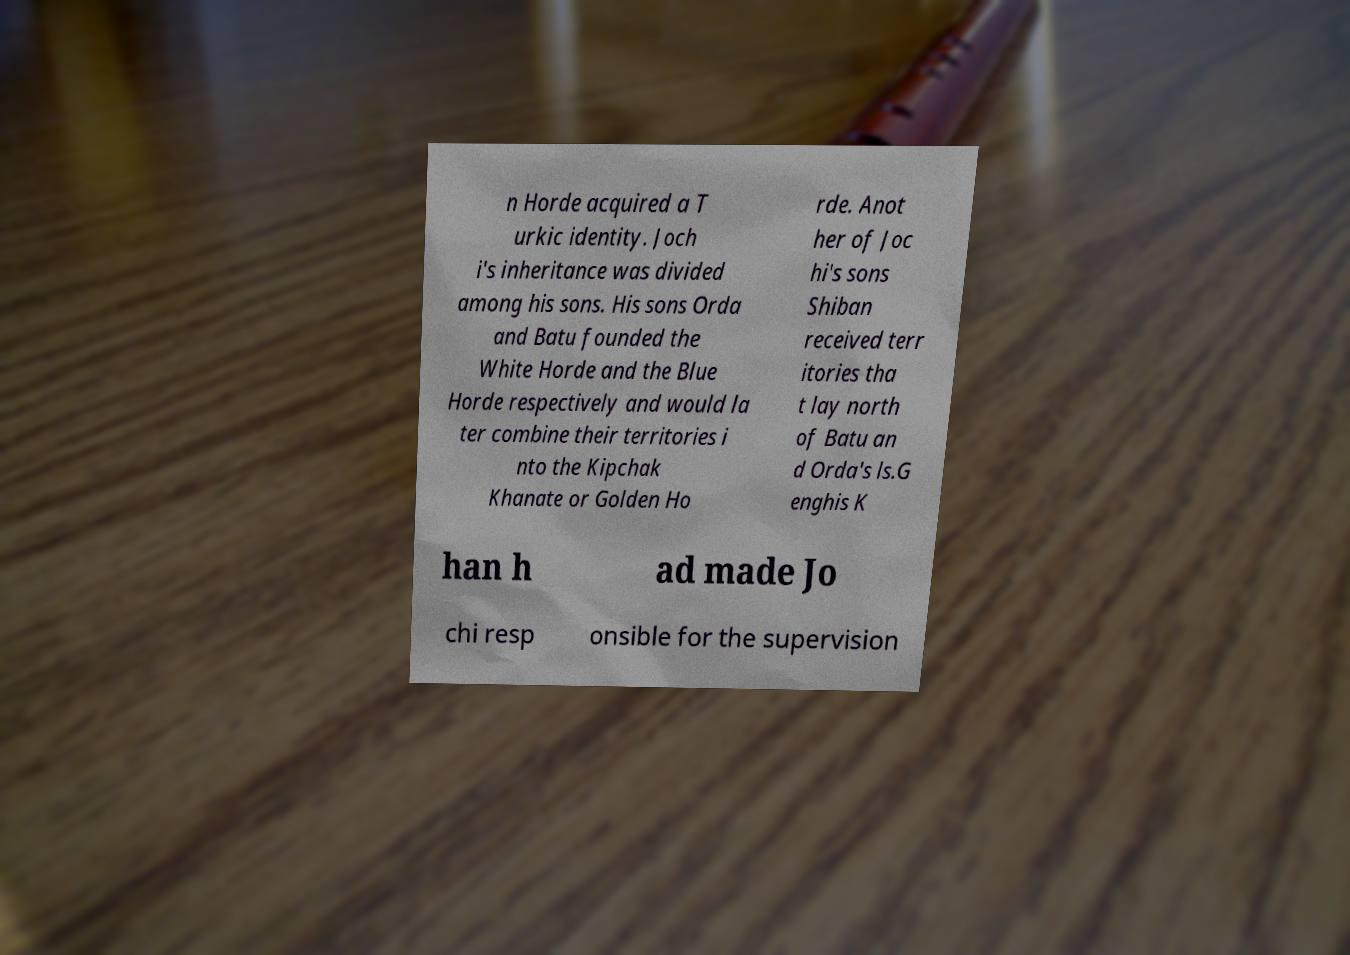I need the written content from this picture converted into text. Can you do that? n Horde acquired a T urkic identity. Joch i's inheritance was divided among his sons. His sons Orda and Batu founded the White Horde and the Blue Horde respectively and would la ter combine their territories i nto the Kipchak Khanate or Golden Ho rde. Anot her of Joc hi's sons Shiban received terr itories tha t lay north of Batu an d Orda's ls.G enghis K han h ad made Jo chi resp onsible for the supervision 